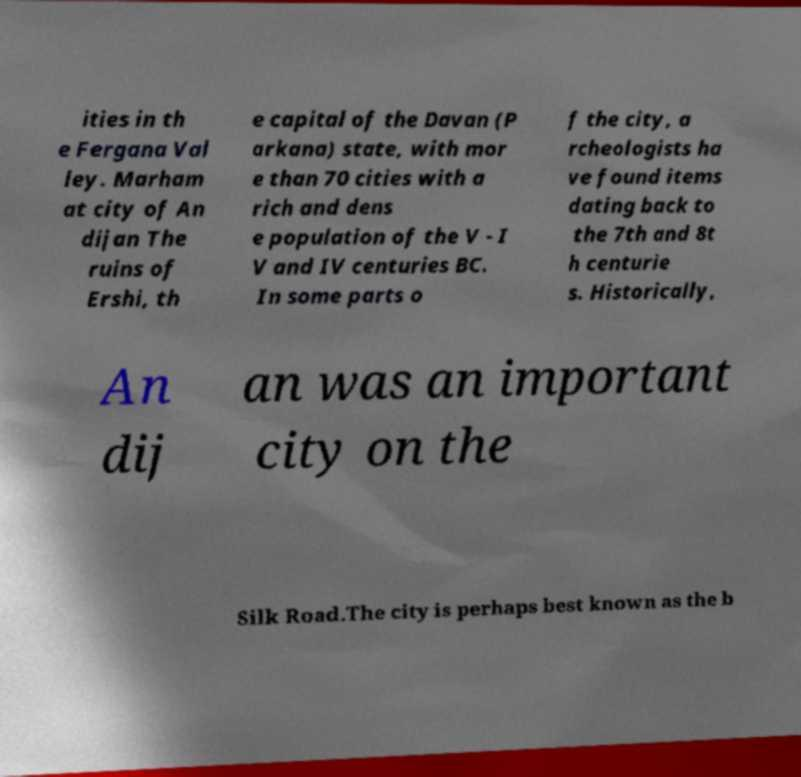Can you read and provide the text displayed in the image?This photo seems to have some interesting text. Can you extract and type it out for me? ities in th e Fergana Val ley. Marham at city of An dijan The ruins of Ershi, th e capital of the Davan (P arkana) state, with mor e than 70 cities with a rich and dens e population of the V - I V and IV centuries BC. In some parts o f the city, a rcheologists ha ve found items dating back to the 7th and 8t h centurie s. Historically, An dij an was an important city on the Silk Road.The city is perhaps best known as the b 